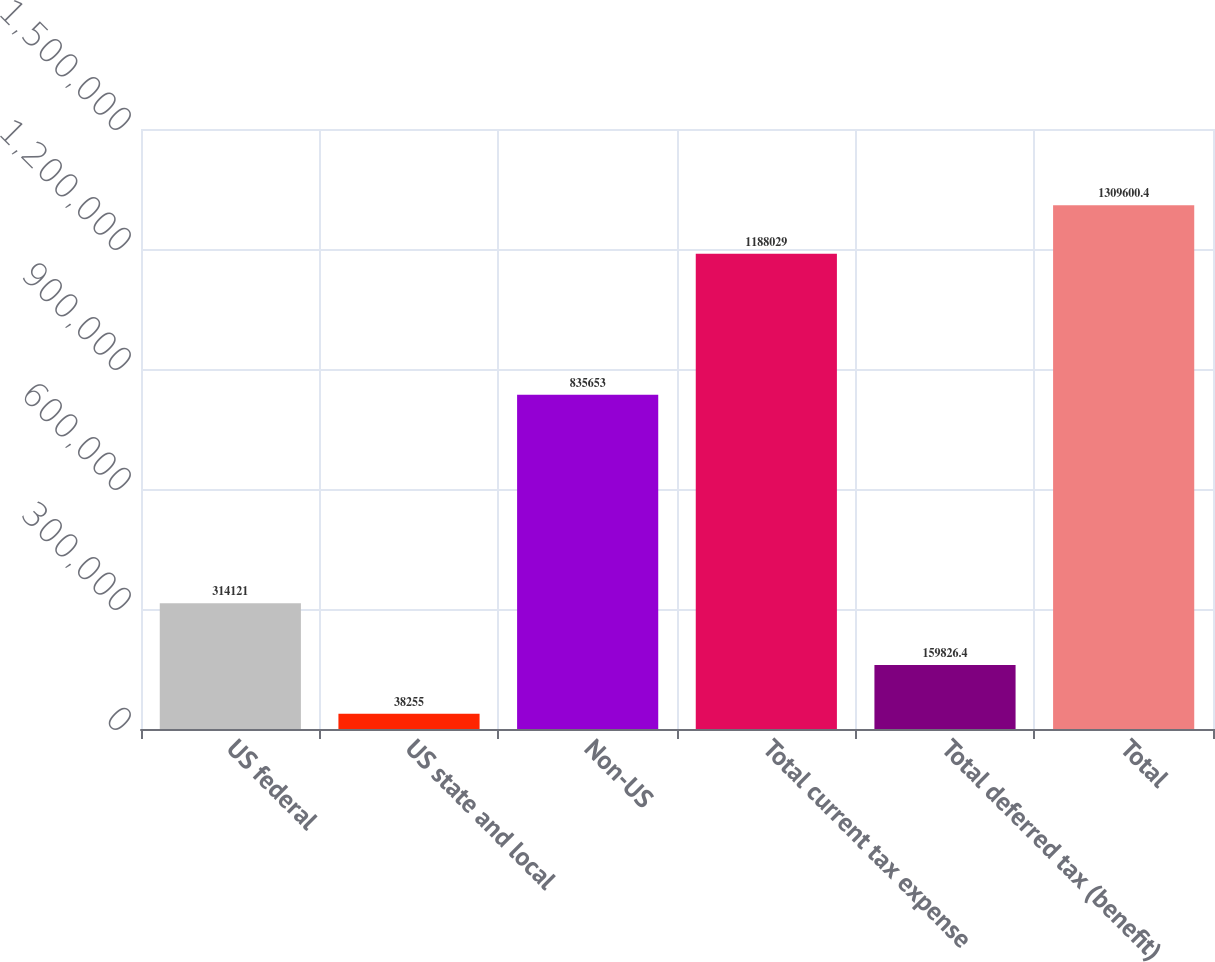Convert chart to OTSL. <chart><loc_0><loc_0><loc_500><loc_500><bar_chart><fcel>US federal<fcel>US state and local<fcel>Non-US<fcel>Total current tax expense<fcel>Total deferred tax (benefit)<fcel>Total<nl><fcel>314121<fcel>38255<fcel>835653<fcel>1.18803e+06<fcel>159826<fcel>1.3096e+06<nl></chart> 